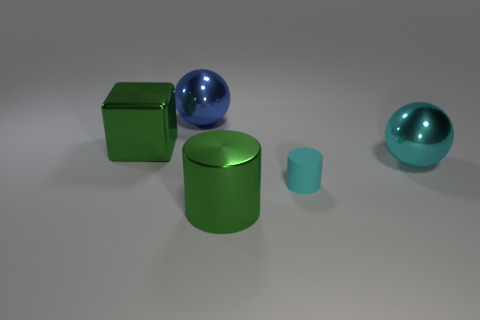Subtract 2 balls. How many balls are left? 0 Subtract all cyan spheres. How many spheres are left? 1 Add 3 small purple matte things. How many objects exist? 8 Subtract all cyan cylinders. Subtract all gray spheres. How many cylinders are left? 1 Subtract all red balls. How many cyan cylinders are left? 1 Subtract all big cyan balls. Subtract all green cylinders. How many objects are left? 3 Add 5 cyan shiny objects. How many cyan shiny objects are left? 6 Add 1 rubber cylinders. How many rubber cylinders exist? 2 Subtract 0 yellow balls. How many objects are left? 5 Subtract all blocks. How many objects are left? 4 